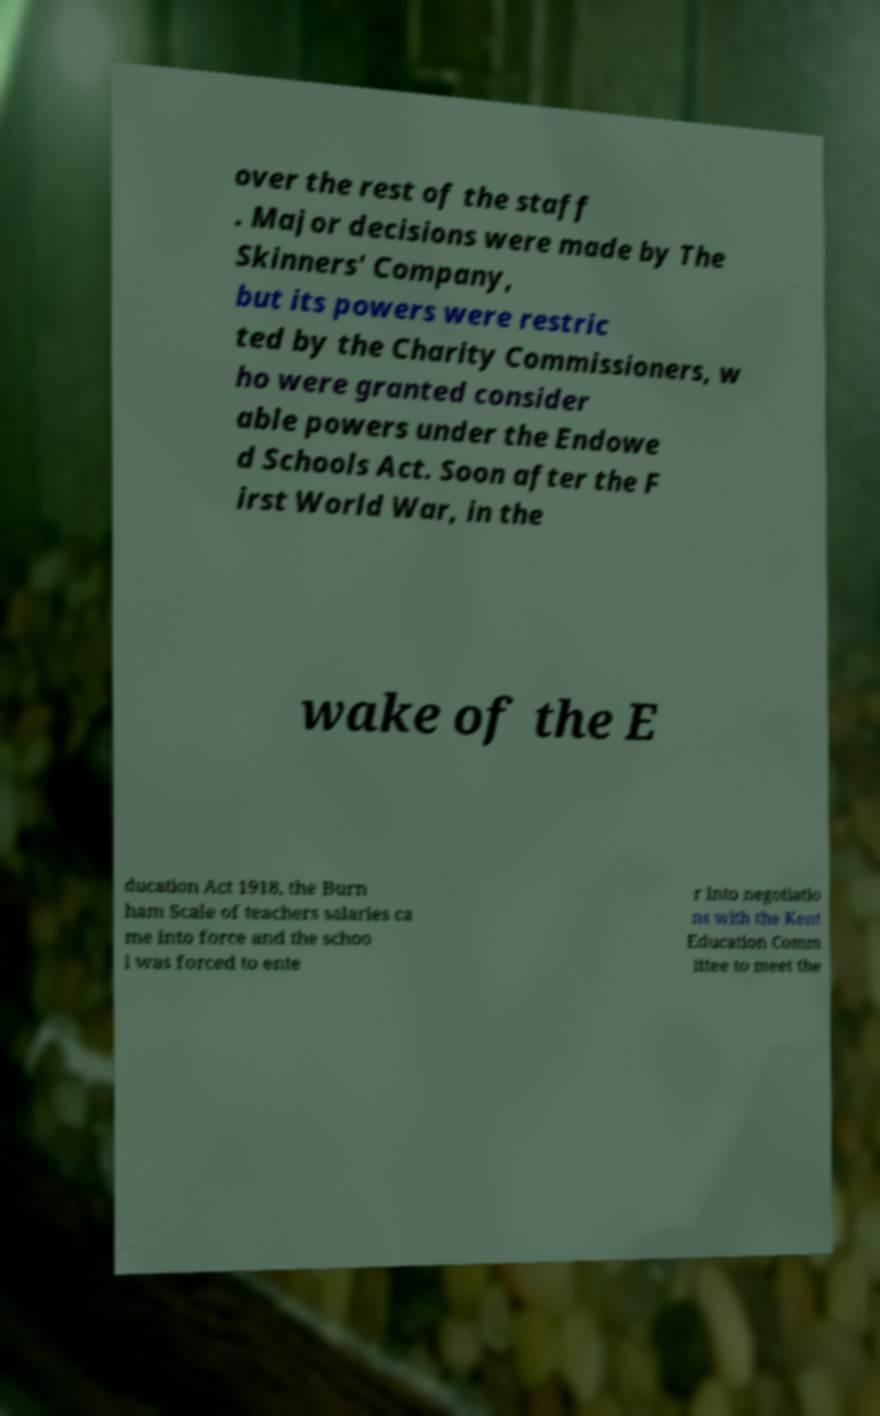Can you accurately transcribe the text from the provided image for me? over the rest of the staff . Major decisions were made by The Skinners' Company, but its powers were restric ted by the Charity Commissioners, w ho were granted consider able powers under the Endowe d Schools Act. Soon after the F irst World War, in the wake of the E ducation Act 1918, the Burn ham Scale of teachers salaries ca me into force and the schoo l was forced to ente r into negotiatio ns with the Kent Education Comm ittee to meet the 